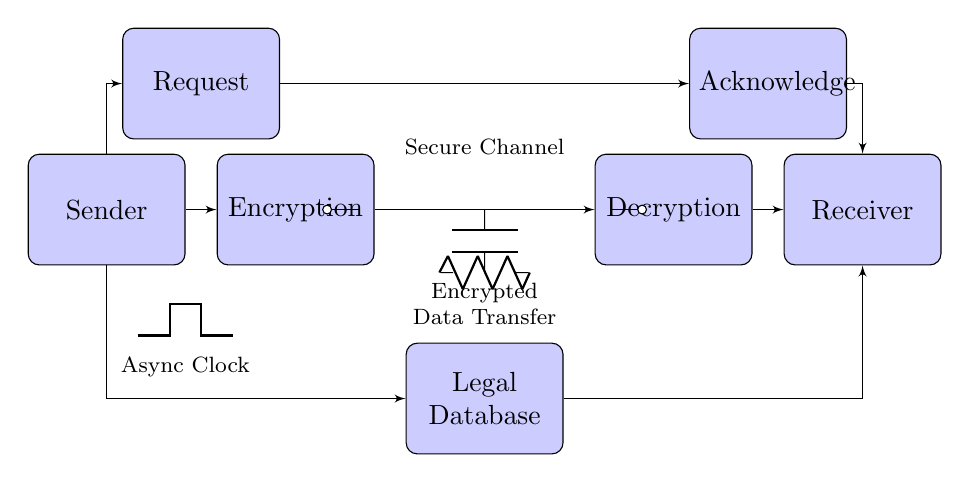What is the primary function of the encryption block? The encryption block's primary function is to secure the data being transferred by converting it into an unreadable format, ensuring confidentiality during the transfer process.
Answer: Secure data What type of circuit is represented in this diagram? This diagram represents an asynchronous handshaking circuit, which is characterized by communication between sender and receiver without a shared clock signal, allowing for flexibility in data transfer timing.
Answer: Asynchronous How many main blocks are present in the circuit? The circuit contains four main operational blocks: Sender, Encryption, Receiver, and Decryption.
Answer: Four What is the role of the request block in this circuit? The request block initiates a communication handshake, signaling the receiver that the sender has data ready for transmission, which is essential in asynchronous communication.
Answer: Initiate communication What does the acknowledge block signify? The acknowledge block indicates that the receiver has successfully received and processed the data, confirming the interaction between sender and receiver in the handshaking process.
Answer: Data received confirmation What type of data transfer does the circuit facilitate? The circuit facilitates encrypted data transfer between the sender and receiver, ensuring the privacy and security of legal databases during communication.
Answer: Encrypted data transfer What is the purpose of the asynchronous clock in this circuit? The asynchronous clock provides timing signals for the data transfer, allowing the sender and receiver to operate independently without needing to synchronize their clocks.
Answer: Timing signals 